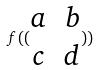Convert formula to latex. <formula><loc_0><loc_0><loc_500><loc_500>f ( ( \begin{matrix} a & b \\ c & d \end{matrix} ) )</formula> 